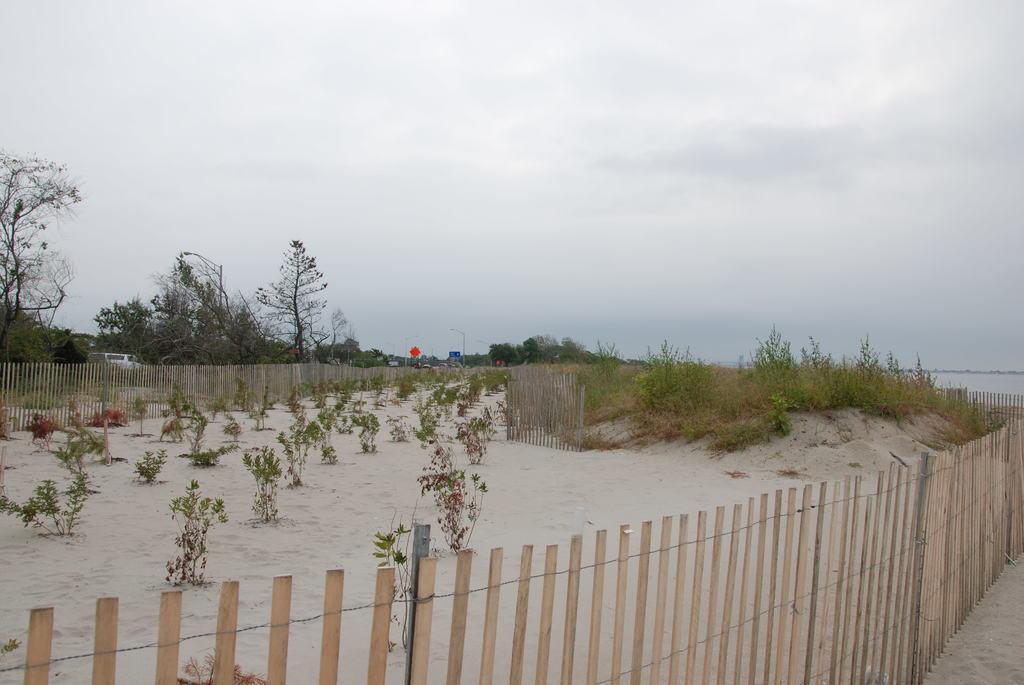Can you describe this image briefly? In this image, we can see some plants in between fences. There are trees on the left side of the image. In the background of the image, there is a sky. 